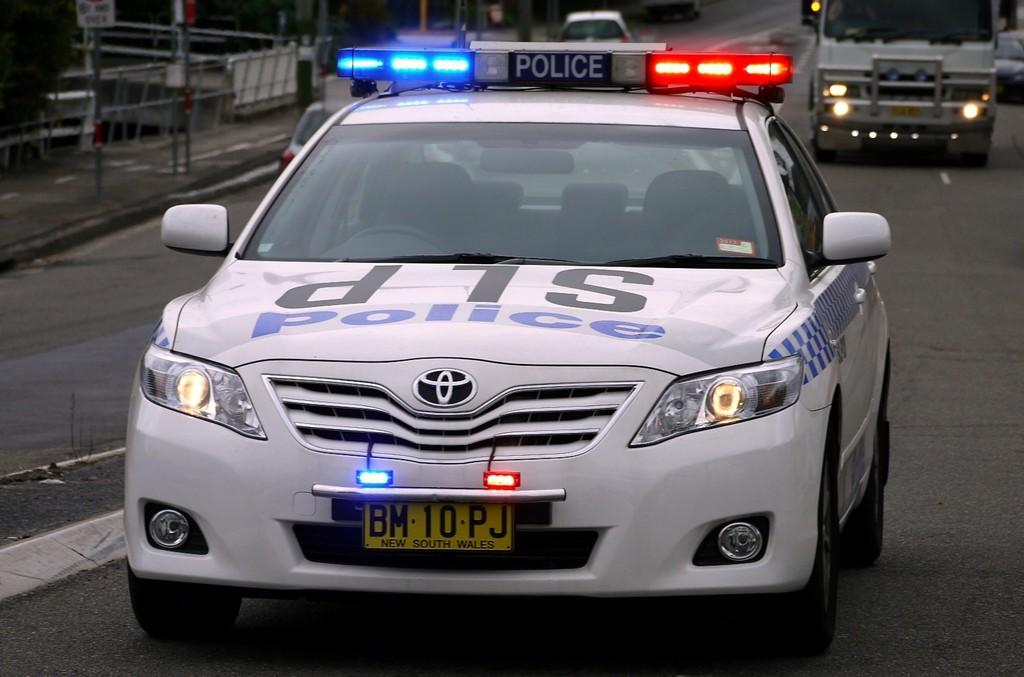What can be seen on the road in the image? There are vehicles on the road in the image. What is located on the left side of the image? There is a rail on the left side of the image. What type of prose is being written by the vehicles on the road in the image? There is no indication in the image that the vehicles are writing any prose. What is the opinion of the rail on the left side of the image? The rail does not have an opinion, as it is an inanimate object. 